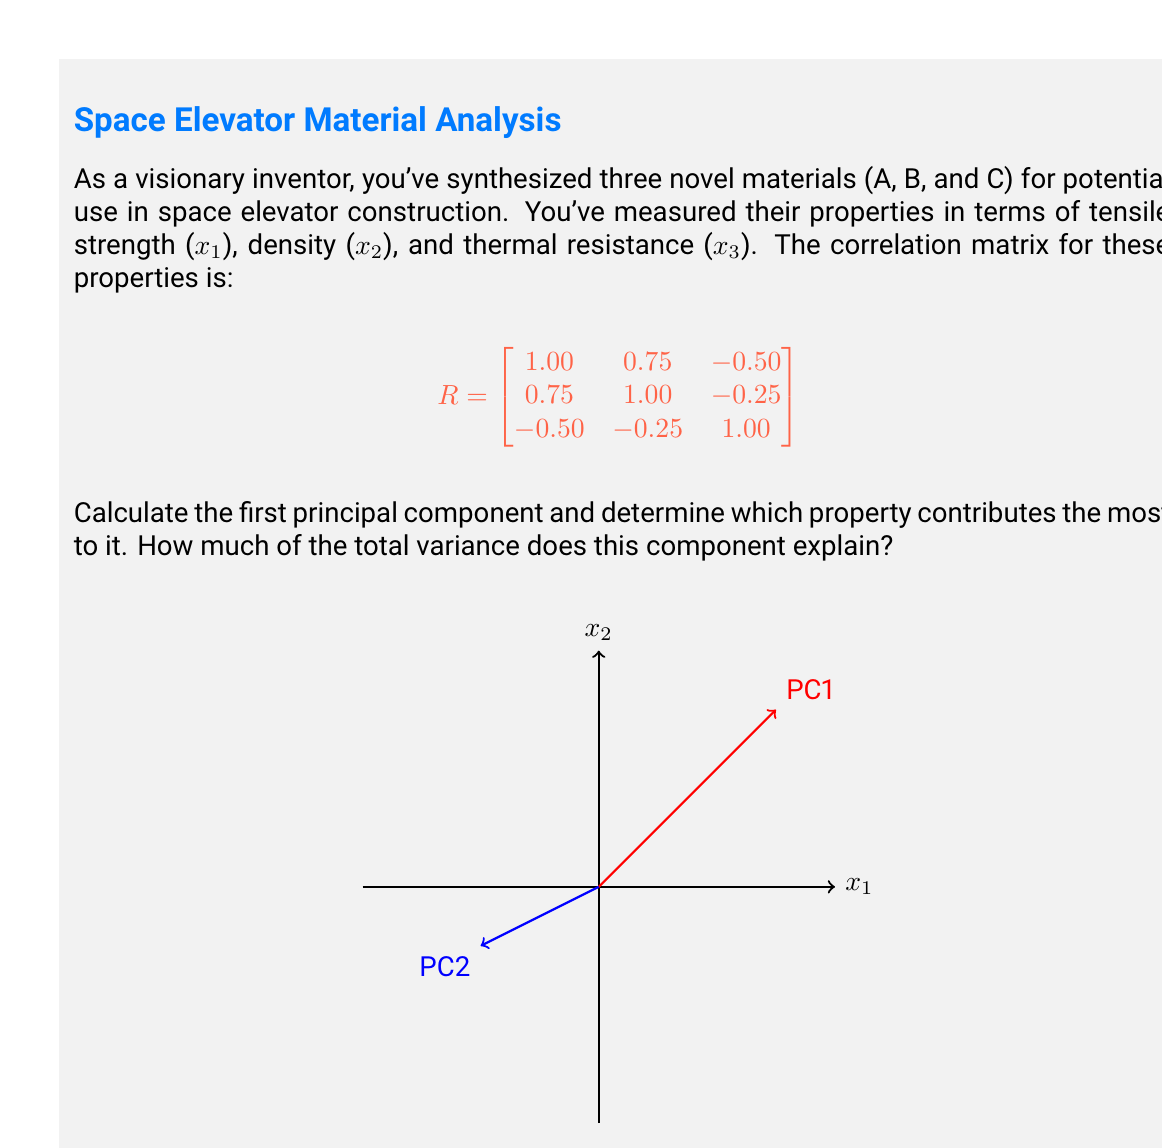Solve this math problem. To solve this problem, we'll follow these steps:

1) First, we need to find the eigenvalues and eigenvectors of the correlation matrix R.

2) The characteristic equation is:
   $$|R - \lambda I| = \begin{vmatrix}
   1-\lambda & 0.75 & -0.50 \\
   0.75 & 1-\lambda & -0.25 \\
   -0.50 & -0.25 & 1-\lambda
   \end{vmatrix} = 0$$

3) Solving this equation gives us the eigenvalues:
   $\lambda_1 \approx 2.0583$, $\lambda_2 \approx 0.7083$, $\lambda_3 \approx 0.2334$

4) The first principal component corresponds to the largest eigenvalue, $\lambda_1 \approx 2.0583$.

5) To find the eigenvector for this eigenvalue, we solve:
   $$(R - 2.0583I)\mathbf{v} = \mathbf{0}$$

6) This gives us the eigenvector (after normalization):
   $$\mathbf{v}_1 \approx [0.6708, 0.6124, -0.4183]^T$$

7) This eigenvector represents the loadings of the first principal component. The largest absolute value determines which property contributes the most.

8) The proportion of variance explained by this component is:
   $$\frac{\lambda_1}{\lambda_1 + \lambda_2 + \lambda_3} = \frac{2.0583}{2.0583 + 0.7083 + 0.2334} \approx 0.6861$$
Answer: First principal component: $[0.6708, 0.6124, -0.4183]^T$. Tensile strength (x₁) contributes most. Explains 68.61% of total variance. 